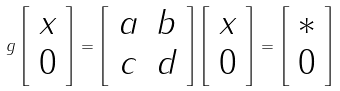<formula> <loc_0><loc_0><loc_500><loc_500>g \left [ \begin{array} { c } x \\ 0 \end{array} \right ] = \left [ \begin{array} { c c } a & b \\ c & d \end{array} \right ] \left [ \begin{array} { c } x \\ 0 \end{array} \right ] = \left [ \begin{array} { c } \ast \\ 0 \end{array} \right ]</formula> 